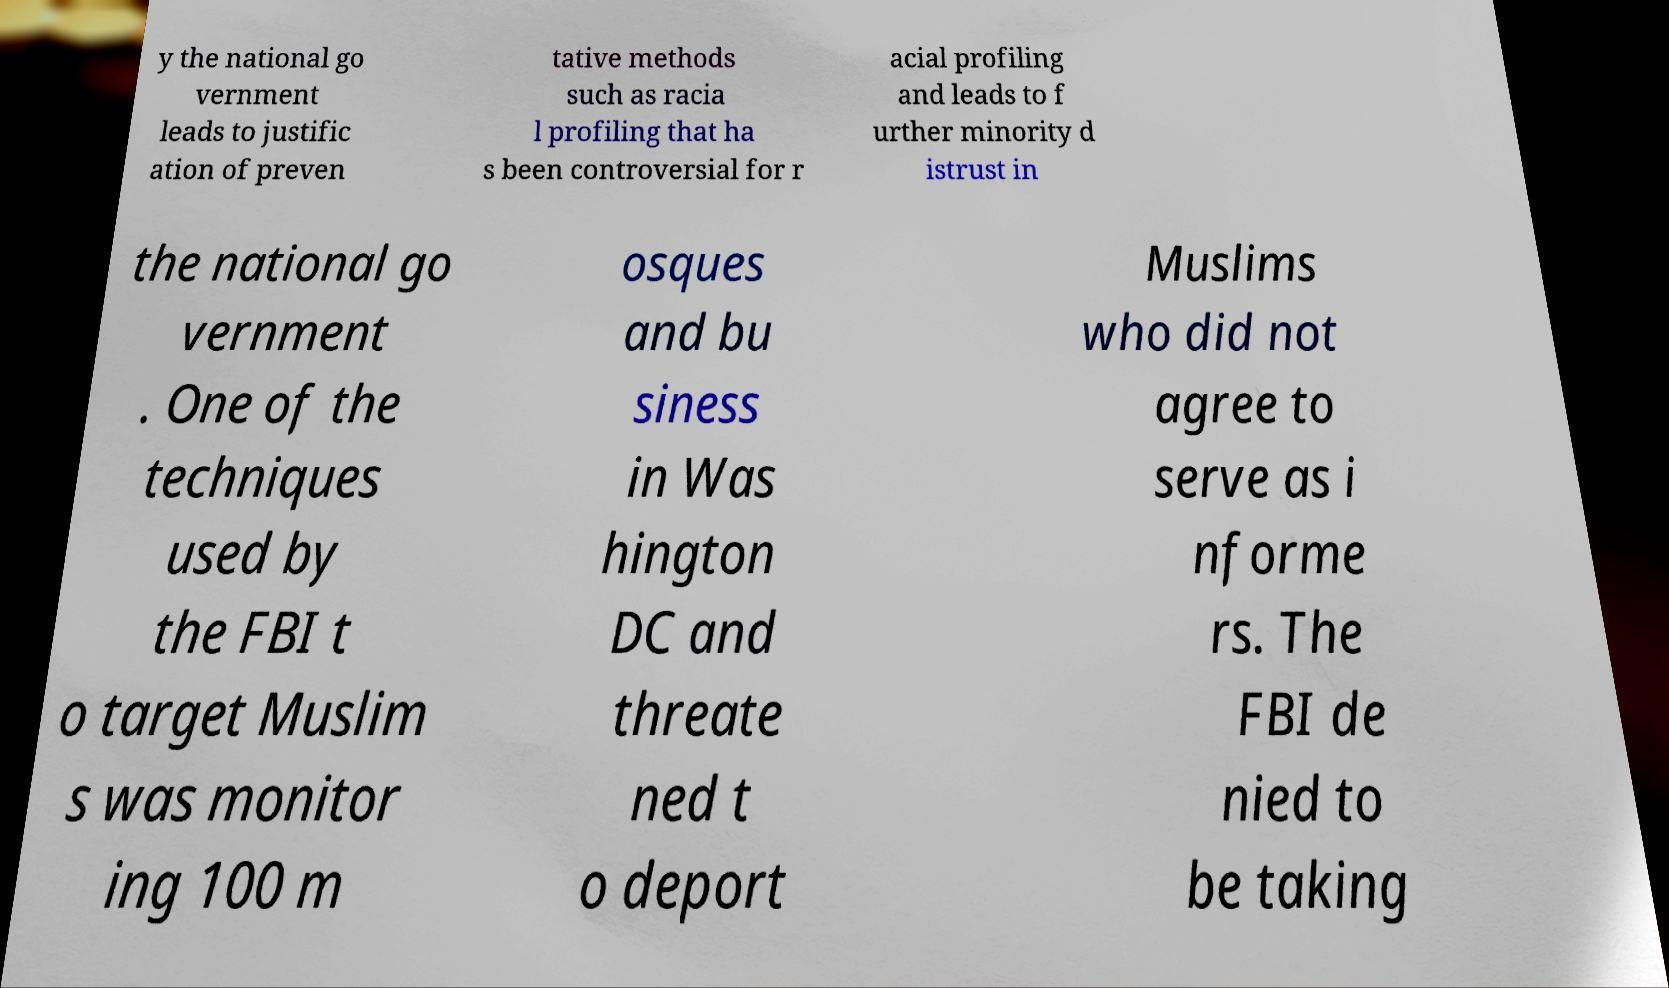Please read and relay the text visible in this image. What does it say? y the national go vernment leads to justific ation of preven tative methods such as racia l profiling that ha s been controversial for r acial profiling and leads to f urther minority d istrust in the national go vernment . One of the techniques used by the FBI t o target Muslim s was monitor ing 100 m osques and bu siness in Was hington DC and threate ned t o deport Muslims who did not agree to serve as i nforme rs. The FBI de nied to be taking 